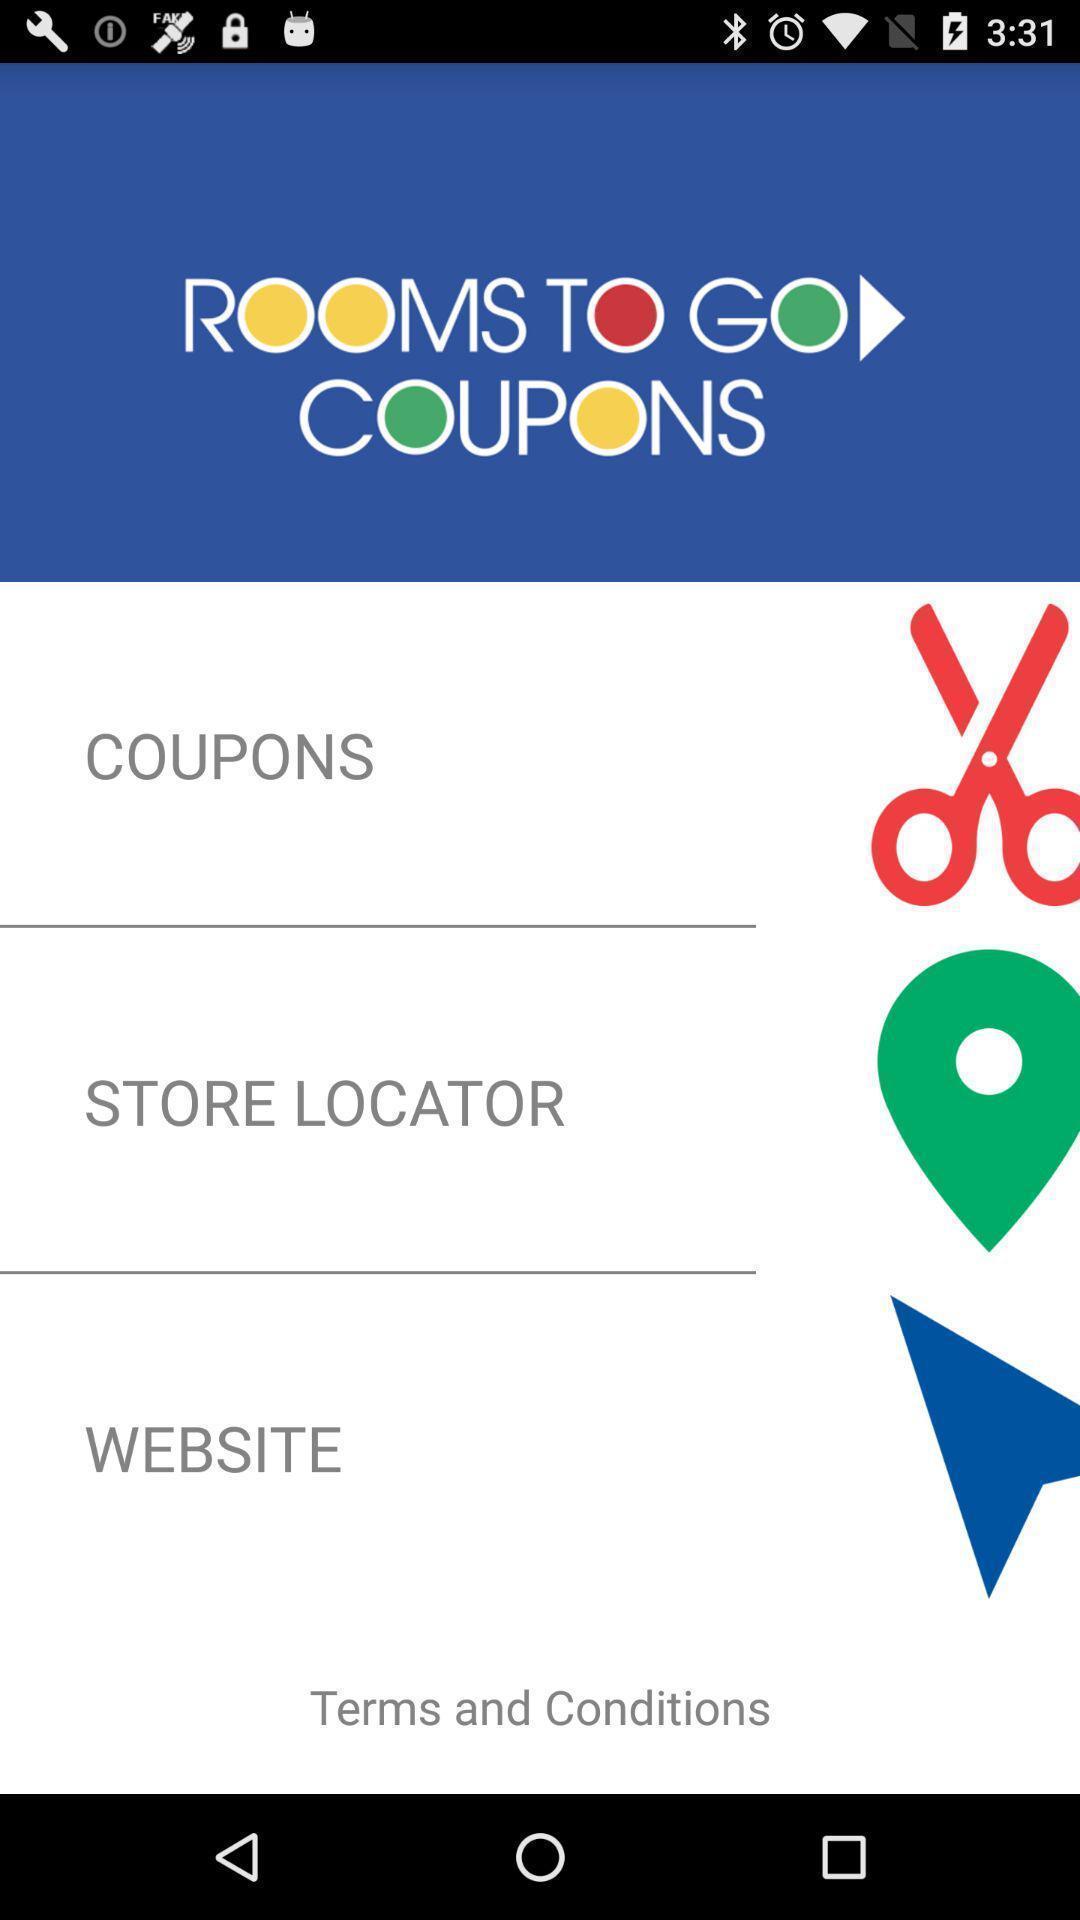Please provide a description for this image. Page showing information about application. 